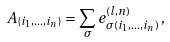Convert formula to latex. <formula><loc_0><loc_0><loc_500><loc_500>A _ { \{ i _ { 1 } , \dots , i _ { n } \} } = \sum _ { \sigma } e ^ { ( l , n ) } _ { \sigma ( i _ { 1 } , \dots , i _ { n } ) } \, ,</formula> 